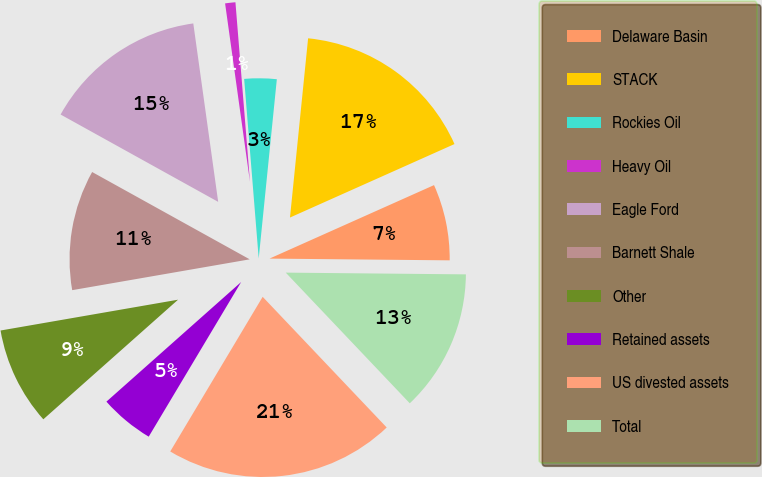<chart> <loc_0><loc_0><loc_500><loc_500><pie_chart><fcel>Delaware Basin<fcel>STACK<fcel>Rockies Oil<fcel>Heavy Oil<fcel>Eagle Ford<fcel>Barnett Shale<fcel>Other<fcel>Retained assets<fcel>US divested assets<fcel>Total<nl><fcel>6.84%<fcel>16.71%<fcel>2.89%<fcel>0.92%<fcel>14.74%<fcel>10.79%<fcel>8.82%<fcel>4.87%<fcel>20.66%<fcel>12.76%<nl></chart> 